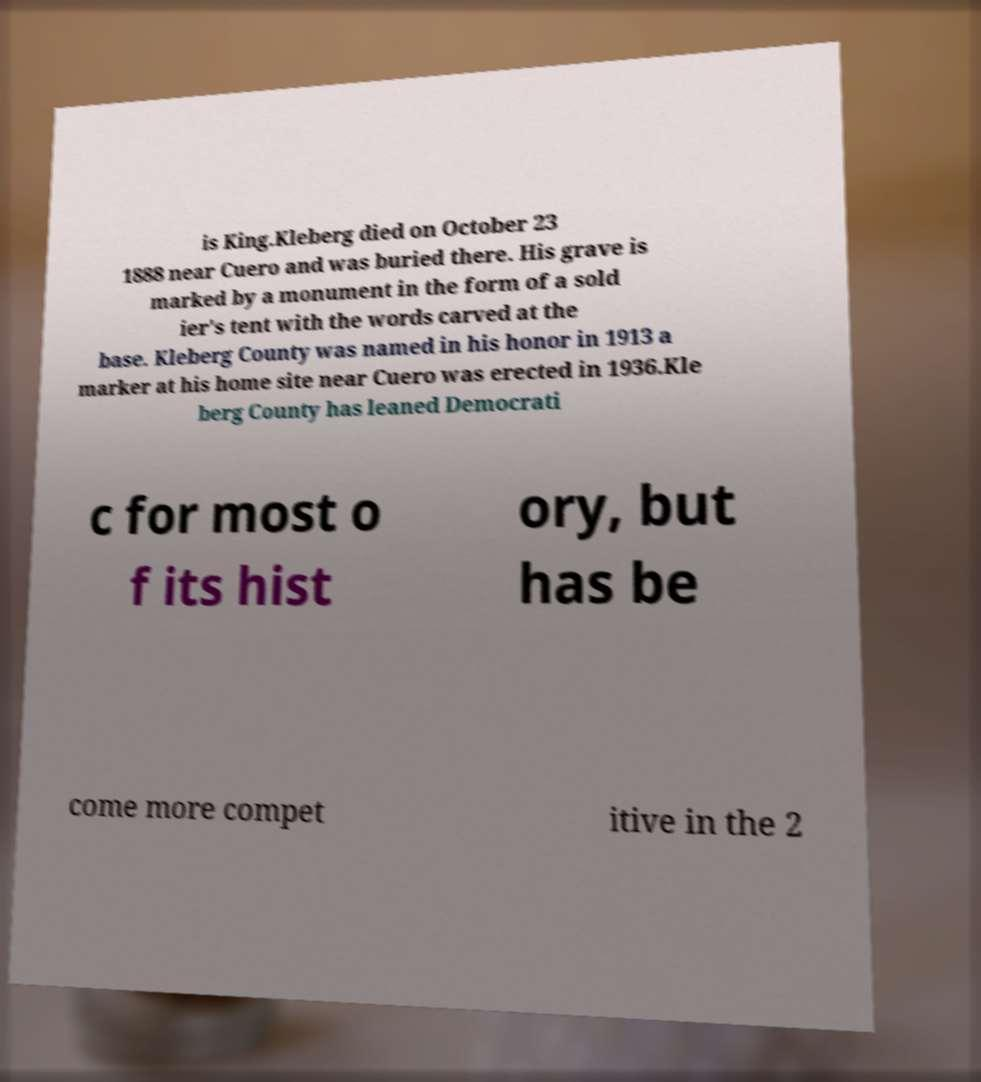For documentation purposes, I need the text within this image transcribed. Could you provide that? is King.Kleberg died on October 23 1888 near Cuero and was buried there. His grave is marked by a monument in the form of a sold ier's tent with the words carved at the base. Kleberg County was named in his honor in 1913 a marker at his home site near Cuero was erected in 1936.Kle berg County has leaned Democrati c for most o f its hist ory, but has be come more compet itive in the 2 